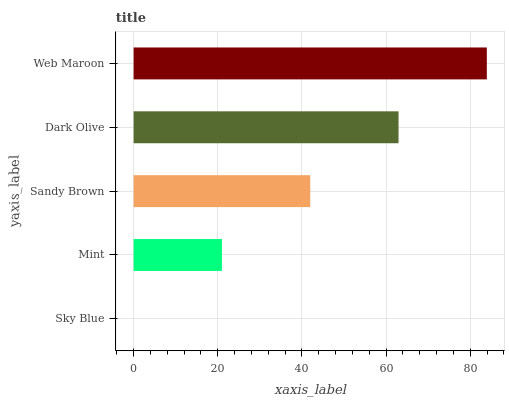Is Sky Blue the minimum?
Answer yes or no. Yes. Is Web Maroon the maximum?
Answer yes or no. Yes. Is Mint the minimum?
Answer yes or no. No. Is Mint the maximum?
Answer yes or no. No. Is Mint greater than Sky Blue?
Answer yes or no. Yes. Is Sky Blue less than Mint?
Answer yes or no. Yes. Is Sky Blue greater than Mint?
Answer yes or no. No. Is Mint less than Sky Blue?
Answer yes or no. No. Is Sandy Brown the high median?
Answer yes or no. Yes. Is Sandy Brown the low median?
Answer yes or no. Yes. Is Web Maroon the high median?
Answer yes or no. No. Is Dark Olive the low median?
Answer yes or no. No. 